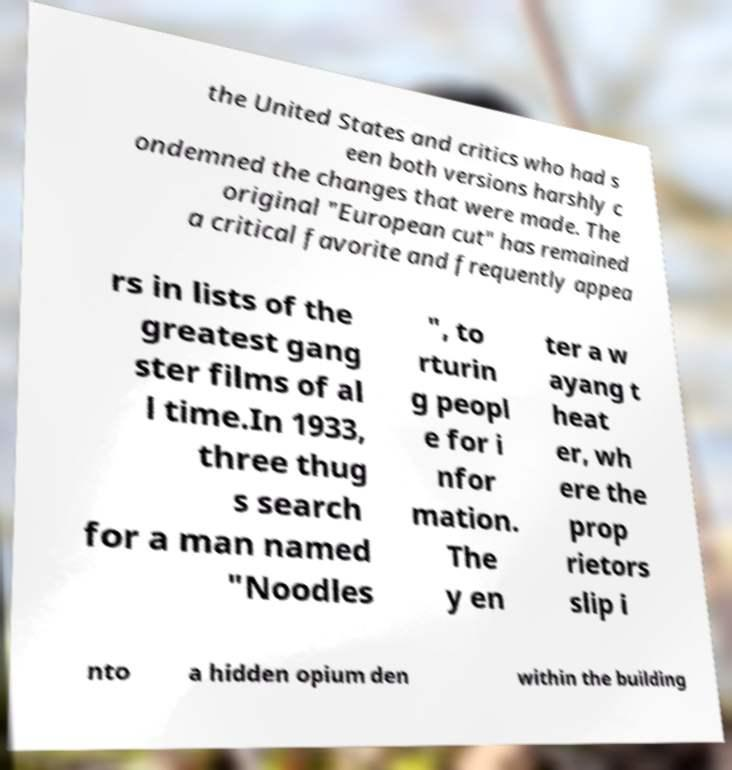Can you accurately transcribe the text from the provided image for me? the United States and critics who had s een both versions harshly c ondemned the changes that were made. The original "European cut" has remained a critical favorite and frequently appea rs in lists of the greatest gang ster films of al l time.In 1933, three thug s search for a man named "Noodles ", to rturin g peopl e for i nfor mation. The y en ter a w ayang t heat er, wh ere the prop rietors slip i nto a hidden opium den within the building 